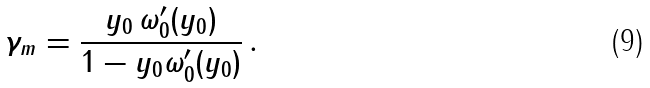Convert formula to latex. <formula><loc_0><loc_0><loc_500><loc_500>\gamma _ { m } = { \frac { y _ { 0 } \, \omega _ { 0 } ^ { \prime } ( y _ { 0 } ) } { 1 - y _ { 0 } \omega _ { 0 } ^ { \prime } ( y _ { 0 } ) } } \, .</formula> 